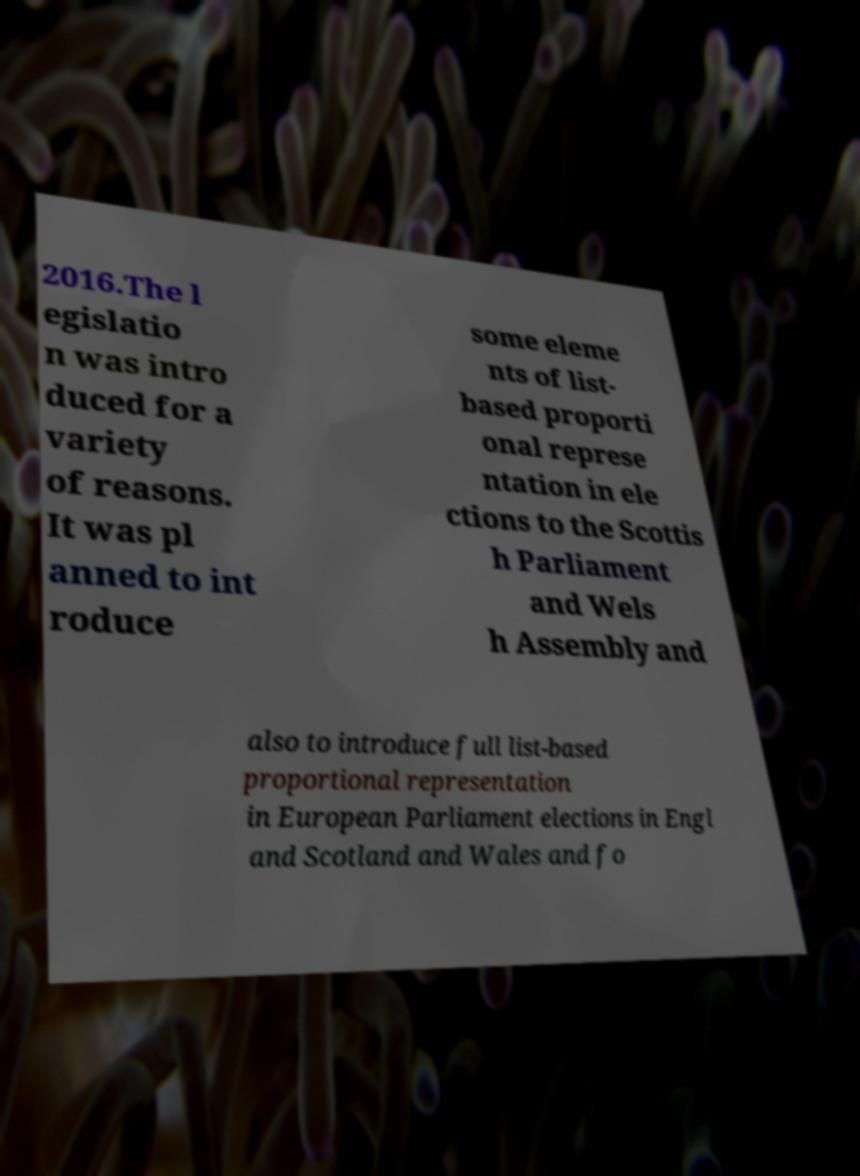Can you read and provide the text displayed in the image?This photo seems to have some interesting text. Can you extract and type it out for me? 2016.The l egislatio n was intro duced for a variety of reasons. It was pl anned to int roduce some eleme nts of list- based proporti onal represe ntation in ele ctions to the Scottis h Parliament and Wels h Assembly and also to introduce full list-based proportional representation in European Parliament elections in Engl and Scotland and Wales and fo 